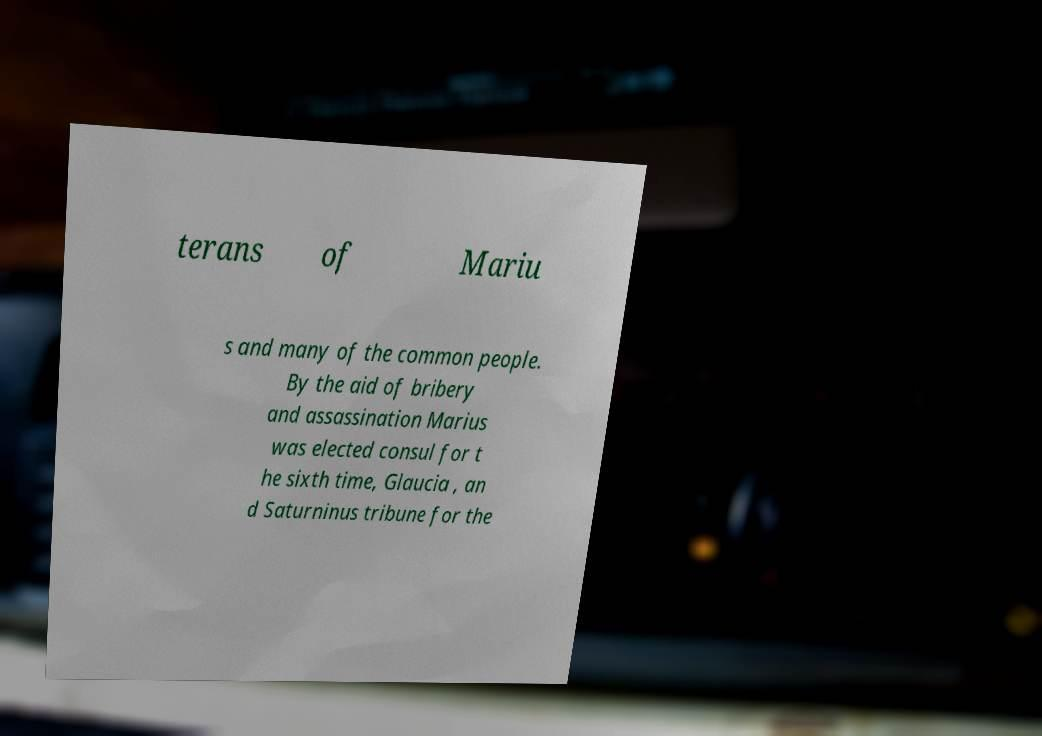Can you read and provide the text displayed in the image?This photo seems to have some interesting text. Can you extract and type it out for me? terans of Mariu s and many of the common people. By the aid of bribery and assassination Marius was elected consul for t he sixth time, Glaucia , an d Saturninus tribune for the 